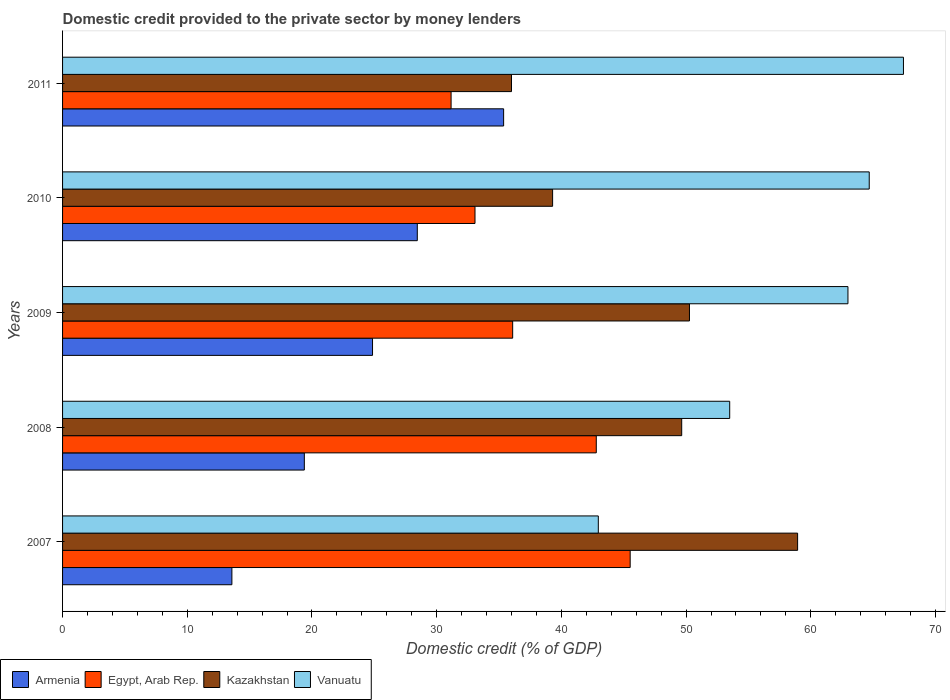How many different coloured bars are there?
Offer a very short reply. 4. How many groups of bars are there?
Offer a terse response. 5. How many bars are there on the 2nd tick from the bottom?
Ensure brevity in your answer.  4. What is the label of the 5th group of bars from the top?
Provide a succinct answer. 2007. In how many cases, is the number of bars for a given year not equal to the number of legend labels?
Provide a succinct answer. 0. What is the domestic credit provided to the private sector by money lenders in Kazakhstan in 2010?
Make the answer very short. 39.3. Across all years, what is the maximum domestic credit provided to the private sector by money lenders in Armenia?
Your answer should be compact. 35.37. Across all years, what is the minimum domestic credit provided to the private sector by money lenders in Vanuatu?
Provide a short and direct response. 42.96. In which year was the domestic credit provided to the private sector by money lenders in Egypt, Arab Rep. maximum?
Your response must be concise. 2007. In which year was the domestic credit provided to the private sector by money lenders in Egypt, Arab Rep. minimum?
Your answer should be compact. 2011. What is the total domestic credit provided to the private sector by money lenders in Egypt, Arab Rep. in the graph?
Keep it short and to the point. 188.63. What is the difference between the domestic credit provided to the private sector by money lenders in Kazakhstan in 2007 and that in 2008?
Your response must be concise. 9.29. What is the difference between the domestic credit provided to the private sector by money lenders in Vanuatu in 2010 and the domestic credit provided to the private sector by money lenders in Kazakhstan in 2008?
Keep it short and to the point. 15.04. What is the average domestic credit provided to the private sector by money lenders in Kazakhstan per year?
Keep it short and to the point. 46.83. In the year 2008, what is the difference between the domestic credit provided to the private sector by money lenders in Armenia and domestic credit provided to the private sector by money lenders in Vanuatu?
Ensure brevity in your answer.  -34.11. What is the ratio of the domestic credit provided to the private sector by money lenders in Kazakhstan in 2010 to that in 2011?
Your response must be concise. 1.09. Is the domestic credit provided to the private sector by money lenders in Kazakhstan in 2009 less than that in 2011?
Make the answer very short. No. Is the difference between the domestic credit provided to the private sector by money lenders in Armenia in 2007 and 2011 greater than the difference between the domestic credit provided to the private sector by money lenders in Vanuatu in 2007 and 2011?
Provide a short and direct response. Yes. What is the difference between the highest and the second highest domestic credit provided to the private sector by money lenders in Egypt, Arab Rep.?
Ensure brevity in your answer.  2.72. What is the difference between the highest and the lowest domestic credit provided to the private sector by money lenders in Kazakhstan?
Give a very brief answer. 22.94. In how many years, is the domestic credit provided to the private sector by money lenders in Kazakhstan greater than the average domestic credit provided to the private sector by money lenders in Kazakhstan taken over all years?
Keep it short and to the point. 3. What does the 1st bar from the top in 2007 represents?
Offer a terse response. Vanuatu. What does the 4th bar from the bottom in 2010 represents?
Provide a short and direct response. Vanuatu. How many years are there in the graph?
Your response must be concise. 5. What is the difference between two consecutive major ticks on the X-axis?
Provide a succinct answer. 10. Does the graph contain any zero values?
Keep it short and to the point. No. Does the graph contain grids?
Keep it short and to the point. No. How many legend labels are there?
Ensure brevity in your answer.  4. What is the title of the graph?
Provide a succinct answer. Domestic credit provided to the private sector by money lenders. Does "Iraq" appear as one of the legend labels in the graph?
Offer a terse response. No. What is the label or title of the X-axis?
Your response must be concise. Domestic credit (% of GDP). What is the Domestic credit (% of GDP) of Armenia in 2007?
Keep it short and to the point. 13.58. What is the Domestic credit (% of GDP) in Egypt, Arab Rep. in 2007?
Give a very brief answer. 45.52. What is the Domestic credit (% of GDP) in Kazakhstan in 2007?
Offer a very short reply. 58.94. What is the Domestic credit (% of GDP) of Vanuatu in 2007?
Your response must be concise. 42.96. What is the Domestic credit (% of GDP) in Armenia in 2008?
Offer a very short reply. 19.39. What is the Domestic credit (% of GDP) in Egypt, Arab Rep. in 2008?
Make the answer very short. 42.8. What is the Domestic credit (% of GDP) in Kazakhstan in 2008?
Give a very brief answer. 49.65. What is the Domestic credit (% of GDP) in Vanuatu in 2008?
Ensure brevity in your answer.  53.5. What is the Domestic credit (% of GDP) of Armenia in 2009?
Make the answer very short. 24.85. What is the Domestic credit (% of GDP) in Egypt, Arab Rep. in 2009?
Ensure brevity in your answer.  36.09. What is the Domestic credit (% of GDP) in Kazakhstan in 2009?
Your answer should be very brief. 50.27. What is the Domestic credit (% of GDP) in Vanuatu in 2009?
Offer a terse response. 62.98. What is the Domestic credit (% of GDP) in Armenia in 2010?
Your response must be concise. 28.45. What is the Domestic credit (% of GDP) of Egypt, Arab Rep. in 2010?
Keep it short and to the point. 33.07. What is the Domestic credit (% of GDP) in Kazakhstan in 2010?
Your answer should be compact. 39.3. What is the Domestic credit (% of GDP) in Vanuatu in 2010?
Provide a succinct answer. 64.69. What is the Domestic credit (% of GDP) of Armenia in 2011?
Provide a succinct answer. 35.37. What is the Domestic credit (% of GDP) of Egypt, Arab Rep. in 2011?
Your response must be concise. 31.15. What is the Domestic credit (% of GDP) of Kazakhstan in 2011?
Provide a succinct answer. 36. What is the Domestic credit (% of GDP) of Vanuatu in 2011?
Your answer should be compact. 67.43. Across all years, what is the maximum Domestic credit (% of GDP) of Armenia?
Offer a terse response. 35.37. Across all years, what is the maximum Domestic credit (% of GDP) of Egypt, Arab Rep.?
Provide a short and direct response. 45.52. Across all years, what is the maximum Domestic credit (% of GDP) in Kazakhstan?
Your answer should be compact. 58.94. Across all years, what is the maximum Domestic credit (% of GDP) in Vanuatu?
Offer a very short reply. 67.43. Across all years, what is the minimum Domestic credit (% of GDP) in Armenia?
Provide a succinct answer. 13.58. Across all years, what is the minimum Domestic credit (% of GDP) of Egypt, Arab Rep.?
Provide a succinct answer. 31.15. Across all years, what is the minimum Domestic credit (% of GDP) of Kazakhstan?
Offer a very short reply. 36. Across all years, what is the minimum Domestic credit (% of GDP) in Vanuatu?
Your answer should be very brief. 42.96. What is the total Domestic credit (% of GDP) in Armenia in the graph?
Your answer should be compact. 121.63. What is the total Domestic credit (% of GDP) in Egypt, Arab Rep. in the graph?
Your response must be concise. 188.63. What is the total Domestic credit (% of GDP) in Kazakhstan in the graph?
Give a very brief answer. 234.15. What is the total Domestic credit (% of GDP) in Vanuatu in the graph?
Ensure brevity in your answer.  291.55. What is the difference between the Domestic credit (% of GDP) in Armenia in 2007 and that in 2008?
Offer a terse response. -5.81. What is the difference between the Domestic credit (% of GDP) in Egypt, Arab Rep. in 2007 and that in 2008?
Keep it short and to the point. 2.72. What is the difference between the Domestic credit (% of GDP) of Kazakhstan in 2007 and that in 2008?
Make the answer very short. 9.29. What is the difference between the Domestic credit (% of GDP) in Vanuatu in 2007 and that in 2008?
Your answer should be very brief. -10.54. What is the difference between the Domestic credit (% of GDP) in Armenia in 2007 and that in 2009?
Your answer should be compact. -11.28. What is the difference between the Domestic credit (% of GDP) in Egypt, Arab Rep. in 2007 and that in 2009?
Make the answer very short. 9.42. What is the difference between the Domestic credit (% of GDP) of Kazakhstan in 2007 and that in 2009?
Provide a succinct answer. 8.67. What is the difference between the Domestic credit (% of GDP) in Vanuatu in 2007 and that in 2009?
Your answer should be compact. -20.02. What is the difference between the Domestic credit (% of GDP) of Armenia in 2007 and that in 2010?
Make the answer very short. -14.87. What is the difference between the Domestic credit (% of GDP) of Egypt, Arab Rep. in 2007 and that in 2010?
Keep it short and to the point. 12.44. What is the difference between the Domestic credit (% of GDP) in Kazakhstan in 2007 and that in 2010?
Your answer should be very brief. 19.65. What is the difference between the Domestic credit (% of GDP) of Vanuatu in 2007 and that in 2010?
Provide a succinct answer. -21.73. What is the difference between the Domestic credit (% of GDP) of Armenia in 2007 and that in 2011?
Your answer should be compact. -21.79. What is the difference between the Domestic credit (% of GDP) in Egypt, Arab Rep. in 2007 and that in 2011?
Keep it short and to the point. 14.36. What is the difference between the Domestic credit (% of GDP) in Kazakhstan in 2007 and that in 2011?
Keep it short and to the point. 22.94. What is the difference between the Domestic credit (% of GDP) in Vanuatu in 2007 and that in 2011?
Make the answer very short. -24.47. What is the difference between the Domestic credit (% of GDP) in Armenia in 2008 and that in 2009?
Offer a very short reply. -5.47. What is the difference between the Domestic credit (% of GDP) in Egypt, Arab Rep. in 2008 and that in 2009?
Give a very brief answer. 6.7. What is the difference between the Domestic credit (% of GDP) in Kazakhstan in 2008 and that in 2009?
Offer a terse response. -0.62. What is the difference between the Domestic credit (% of GDP) of Vanuatu in 2008 and that in 2009?
Your answer should be compact. -9.48. What is the difference between the Domestic credit (% of GDP) of Armenia in 2008 and that in 2010?
Keep it short and to the point. -9.06. What is the difference between the Domestic credit (% of GDP) in Egypt, Arab Rep. in 2008 and that in 2010?
Provide a short and direct response. 9.73. What is the difference between the Domestic credit (% of GDP) in Kazakhstan in 2008 and that in 2010?
Your answer should be compact. 10.35. What is the difference between the Domestic credit (% of GDP) in Vanuatu in 2008 and that in 2010?
Offer a terse response. -11.19. What is the difference between the Domestic credit (% of GDP) of Armenia in 2008 and that in 2011?
Offer a very short reply. -15.98. What is the difference between the Domestic credit (% of GDP) in Egypt, Arab Rep. in 2008 and that in 2011?
Keep it short and to the point. 11.64. What is the difference between the Domestic credit (% of GDP) in Kazakhstan in 2008 and that in 2011?
Ensure brevity in your answer.  13.65. What is the difference between the Domestic credit (% of GDP) in Vanuatu in 2008 and that in 2011?
Provide a succinct answer. -13.93. What is the difference between the Domestic credit (% of GDP) in Armenia in 2009 and that in 2010?
Give a very brief answer. -3.59. What is the difference between the Domestic credit (% of GDP) in Egypt, Arab Rep. in 2009 and that in 2010?
Provide a succinct answer. 3.02. What is the difference between the Domestic credit (% of GDP) of Kazakhstan in 2009 and that in 2010?
Give a very brief answer. 10.97. What is the difference between the Domestic credit (% of GDP) in Vanuatu in 2009 and that in 2010?
Offer a terse response. -1.71. What is the difference between the Domestic credit (% of GDP) of Armenia in 2009 and that in 2011?
Ensure brevity in your answer.  -10.51. What is the difference between the Domestic credit (% of GDP) in Egypt, Arab Rep. in 2009 and that in 2011?
Offer a very short reply. 4.94. What is the difference between the Domestic credit (% of GDP) in Kazakhstan in 2009 and that in 2011?
Offer a very short reply. 14.27. What is the difference between the Domestic credit (% of GDP) in Vanuatu in 2009 and that in 2011?
Ensure brevity in your answer.  -4.45. What is the difference between the Domestic credit (% of GDP) in Armenia in 2010 and that in 2011?
Offer a very short reply. -6.92. What is the difference between the Domestic credit (% of GDP) of Egypt, Arab Rep. in 2010 and that in 2011?
Your answer should be very brief. 1.92. What is the difference between the Domestic credit (% of GDP) in Kazakhstan in 2010 and that in 2011?
Give a very brief answer. 3.3. What is the difference between the Domestic credit (% of GDP) of Vanuatu in 2010 and that in 2011?
Provide a succinct answer. -2.74. What is the difference between the Domestic credit (% of GDP) in Armenia in 2007 and the Domestic credit (% of GDP) in Egypt, Arab Rep. in 2008?
Keep it short and to the point. -29.22. What is the difference between the Domestic credit (% of GDP) in Armenia in 2007 and the Domestic credit (% of GDP) in Kazakhstan in 2008?
Offer a very short reply. -36.07. What is the difference between the Domestic credit (% of GDP) of Armenia in 2007 and the Domestic credit (% of GDP) of Vanuatu in 2008?
Offer a terse response. -39.92. What is the difference between the Domestic credit (% of GDP) of Egypt, Arab Rep. in 2007 and the Domestic credit (% of GDP) of Kazakhstan in 2008?
Provide a short and direct response. -4.13. What is the difference between the Domestic credit (% of GDP) of Egypt, Arab Rep. in 2007 and the Domestic credit (% of GDP) of Vanuatu in 2008?
Offer a terse response. -7.98. What is the difference between the Domestic credit (% of GDP) in Kazakhstan in 2007 and the Domestic credit (% of GDP) in Vanuatu in 2008?
Your response must be concise. 5.44. What is the difference between the Domestic credit (% of GDP) in Armenia in 2007 and the Domestic credit (% of GDP) in Egypt, Arab Rep. in 2009?
Offer a very short reply. -22.51. What is the difference between the Domestic credit (% of GDP) in Armenia in 2007 and the Domestic credit (% of GDP) in Kazakhstan in 2009?
Offer a terse response. -36.69. What is the difference between the Domestic credit (% of GDP) in Armenia in 2007 and the Domestic credit (% of GDP) in Vanuatu in 2009?
Make the answer very short. -49.4. What is the difference between the Domestic credit (% of GDP) in Egypt, Arab Rep. in 2007 and the Domestic credit (% of GDP) in Kazakhstan in 2009?
Offer a terse response. -4.75. What is the difference between the Domestic credit (% of GDP) in Egypt, Arab Rep. in 2007 and the Domestic credit (% of GDP) in Vanuatu in 2009?
Give a very brief answer. -17.46. What is the difference between the Domestic credit (% of GDP) in Kazakhstan in 2007 and the Domestic credit (% of GDP) in Vanuatu in 2009?
Offer a terse response. -4.04. What is the difference between the Domestic credit (% of GDP) of Armenia in 2007 and the Domestic credit (% of GDP) of Egypt, Arab Rep. in 2010?
Offer a terse response. -19.49. What is the difference between the Domestic credit (% of GDP) of Armenia in 2007 and the Domestic credit (% of GDP) of Kazakhstan in 2010?
Your answer should be compact. -25.72. What is the difference between the Domestic credit (% of GDP) of Armenia in 2007 and the Domestic credit (% of GDP) of Vanuatu in 2010?
Provide a succinct answer. -51.11. What is the difference between the Domestic credit (% of GDP) in Egypt, Arab Rep. in 2007 and the Domestic credit (% of GDP) in Kazakhstan in 2010?
Give a very brief answer. 6.22. What is the difference between the Domestic credit (% of GDP) in Egypt, Arab Rep. in 2007 and the Domestic credit (% of GDP) in Vanuatu in 2010?
Make the answer very short. -19.17. What is the difference between the Domestic credit (% of GDP) of Kazakhstan in 2007 and the Domestic credit (% of GDP) of Vanuatu in 2010?
Give a very brief answer. -5.74. What is the difference between the Domestic credit (% of GDP) of Armenia in 2007 and the Domestic credit (% of GDP) of Egypt, Arab Rep. in 2011?
Your response must be concise. -17.58. What is the difference between the Domestic credit (% of GDP) of Armenia in 2007 and the Domestic credit (% of GDP) of Kazakhstan in 2011?
Your response must be concise. -22.42. What is the difference between the Domestic credit (% of GDP) in Armenia in 2007 and the Domestic credit (% of GDP) in Vanuatu in 2011?
Provide a short and direct response. -53.85. What is the difference between the Domestic credit (% of GDP) in Egypt, Arab Rep. in 2007 and the Domestic credit (% of GDP) in Kazakhstan in 2011?
Provide a succinct answer. 9.52. What is the difference between the Domestic credit (% of GDP) in Egypt, Arab Rep. in 2007 and the Domestic credit (% of GDP) in Vanuatu in 2011?
Keep it short and to the point. -21.91. What is the difference between the Domestic credit (% of GDP) in Kazakhstan in 2007 and the Domestic credit (% of GDP) in Vanuatu in 2011?
Keep it short and to the point. -8.49. What is the difference between the Domestic credit (% of GDP) in Armenia in 2008 and the Domestic credit (% of GDP) in Egypt, Arab Rep. in 2009?
Your response must be concise. -16.71. What is the difference between the Domestic credit (% of GDP) of Armenia in 2008 and the Domestic credit (% of GDP) of Kazakhstan in 2009?
Offer a terse response. -30.88. What is the difference between the Domestic credit (% of GDP) of Armenia in 2008 and the Domestic credit (% of GDP) of Vanuatu in 2009?
Offer a very short reply. -43.59. What is the difference between the Domestic credit (% of GDP) of Egypt, Arab Rep. in 2008 and the Domestic credit (% of GDP) of Kazakhstan in 2009?
Your answer should be compact. -7.47. What is the difference between the Domestic credit (% of GDP) of Egypt, Arab Rep. in 2008 and the Domestic credit (% of GDP) of Vanuatu in 2009?
Your answer should be compact. -20.18. What is the difference between the Domestic credit (% of GDP) of Kazakhstan in 2008 and the Domestic credit (% of GDP) of Vanuatu in 2009?
Give a very brief answer. -13.33. What is the difference between the Domestic credit (% of GDP) of Armenia in 2008 and the Domestic credit (% of GDP) of Egypt, Arab Rep. in 2010?
Offer a very short reply. -13.69. What is the difference between the Domestic credit (% of GDP) of Armenia in 2008 and the Domestic credit (% of GDP) of Kazakhstan in 2010?
Your response must be concise. -19.91. What is the difference between the Domestic credit (% of GDP) of Armenia in 2008 and the Domestic credit (% of GDP) of Vanuatu in 2010?
Your response must be concise. -45.3. What is the difference between the Domestic credit (% of GDP) in Egypt, Arab Rep. in 2008 and the Domestic credit (% of GDP) in Kazakhstan in 2010?
Give a very brief answer. 3.5. What is the difference between the Domestic credit (% of GDP) in Egypt, Arab Rep. in 2008 and the Domestic credit (% of GDP) in Vanuatu in 2010?
Keep it short and to the point. -21.89. What is the difference between the Domestic credit (% of GDP) in Kazakhstan in 2008 and the Domestic credit (% of GDP) in Vanuatu in 2010?
Offer a terse response. -15.04. What is the difference between the Domestic credit (% of GDP) in Armenia in 2008 and the Domestic credit (% of GDP) in Egypt, Arab Rep. in 2011?
Your answer should be compact. -11.77. What is the difference between the Domestic credit (% of GDP) in Armenia in 2008 and the Domestic credit (% of GDP) in Kazakhstan in 2011?
Your answer should be compact. -16.61. What is the difference between the Domestic credit (% of GDP) in Armenia in 2008 and the Domestic credit (% of GDP) in Vanuatu in 2011?
Your response must be concise. -48.04. What is the difference between the Domestic credit (% of GDP) of Egypt, Arab Rep. in 2008 and the Domestic credit (% of GDP) of Kazakhstan in 2011?
Keep it short and to the point. 6.8. What is the difference between the Domestic credit (% of GDP) of Egypt, Arab Rep. in 2008 and the Domestic credit (% of GDP) of Vanuatu in 2011?
Give a very brief answer. -24.63. What is the difference between the Domestic credit (% of GDP) of Kazakhstan in 2008 and the Domestic credit (% of GDP) of Vanuatu in 2011?
Make the answer very short. -17.78. What is the difference between the Domestic credit (% of GDP) in Armenia in 2009 and the Domestic credit (% of GDP) in Egypt, Arab Rep. in 2010?
Provide a succinct answer. -8.22. What is the difference between the Domestic credit (% of GDP) of Armenia in 2009 and the Domestic credit (% of GDP) of Kazakhstan in 2010?
Your answer should be compact. -14.44. What is the difference between the Domestic credit (% of GDP) of Armenia in 2009 and the Domestic credit (% of GDP) of Vanuatu in 2010?
Make the answer very short. -39.83. What is the difference between the Domestic credit (% of GDP) in Egypt, Arab Rep. in 2009 and the Domestic credit (% of GDP) in Kazakhstan in 2010?
Your answer should be compact. -3.2. What is the difference between the Domestic credit (% of GDP) of Egypt, Arab Rep. in 2009 and the Domestic credit (% of GDP) of Vanuatu in 2010?
Provide a short and direct response. -28.59. What is the difference between the Domestic credit (% of GDP) of Kazakhstan in 2009 and the Domestic credit (% of GDP) of Vanuatu in 2010?
Make the answer very short. -14.42. What is the difference between the Domestic credit (% of GDP) of Armenia in 2009 and the Domestic credit (% of GDP) of Kazakhstan in 2011?
Your answer should be very brief. -11.14. What is the difference between the Domestic credit (% of GDP) of Armenia in 2009 and the Domestic credit (% of GDP) of Vanuatu in 2011?
Provide a succinct answer. -42.57. What is the difference between the Domestic credit (% of GDP) in Egypt, Arab Rep. in 2009 and the Domestic credit (% of GDP) in Kazakhstan in 2011?
Your answer should be compact. 0.09. What is the difference between the Domestic credit (% of GDP) of Egypt, Arab Rep. in 2009 and the Domestic credit (% of GDP) of Vanuatu in 2011?
Your response must be concise. -31.34. What is the difference between the Domestic credit (% of GDP) in Kazakhstan in 2009 and the Domestic credit (% of GDP) in Vanuatu in 2011?
Make the answer very short. -17.16. What is the difference between the Domestic credit (% of GDP) of Armenia in 2010 and the Domestic credit (% of GDP) of Egypt, Arab Rep. in 2011?
Your answer should be very brief. -2.71. What is the difference between the Domestic credit (% of GDP) of Armenia in 2010 and the Domestic credit (% of GDP) of Kazakhstan in 2011?
Give a very brief answer. -7.55. What is the difference between the Domestic credit (% of GDP) in Armenia in 2010 and the Domestic credit (% of GDP) in Vanuatu in 2011?
Provide a short and direct response. -38.98. What is the difference between the Domestic credit (% of GDP) in Egypt, Arab Rep. in 2010 and the Domestic credit (% of GDP) in Kazakhstan in 2011?
Give a very brief answer. -2.93. What is the difference between the Domestic credit (% of GDP) in Egypt, Arab Rep. in 2010 and the Domestic credit (% of GDP) in Vanuatu in 2011?
Provide a succinct answer. -34.36. What is the difference between the Domestic credit (% of GDP) in Kazakhstan in 2010 and the Domestic credit (% of GDP) in Vanuatu in 2011?
Your response must be concise. -28.13. What is the average Domestic credit (% of GDP) in Armenia per year?
Ensure brevity in your answer.  24.33. What is the average Domestic credit (% of GDP) in Egypt, Arab Rep. per year?
Provide a short and direct response. 37.73. What is the average Domestic credit (% of GDP) in Kazakhstan per year?
Your answer should be very brief. 46.83. What is the average Domestic credit (% of GDP) in Vanuatu per year?
Provide a succinct answer. 58.31. In the year 2007, what is the difference between the Domestic credit (% of GDP) of Armenia and Domestic credit (% of GDP) of Egypt, Arab Rep.?
Provide a succinct answer. -31.94. In the year 2007, what is the difference between the Domestic credit (% of GDP) in Armenia and Domestic credit (% of GDP) in Kazakhstan?
Provide a succinct answer. -45.36. In the year 2007, what is the difference between the Domestic credit (% of GDP) of Armenia and Domestic credit (% of GDP) of Vanuatu?
Your answer should be very brief. -29.38. In the year 2007, what is the difference between the Domestic credit (% of GDP) in Egypt, Arab Rep. and Domestic credit (% of GDP) in Kazakhstan?
Ensure brevity in your answer.  -13.43. In the year 2007, what is the difference between the Domestic credit (% of GDP) in Egypt, Arab Rep. and Domestic credit (% of GDP) in Vanuatu?
Ensure brevity in your answer.  2.56. In the year 2007, what is the difference between the Domestic credit (% of GDP) in Kazakhstan and Domestic credit (% of GDP) in Vanuatu?
Make the answer very short. 15.98. In the year 2008, what is the difference between the Domestic credit (% of GDP) of Armenia and Domestic credit (% of GDP) of Egypt, Arab Rep.?
Offer a terse response. -23.41. In the year 2008, what is the difference between the Domestic credit (% of GDP) of Armenia and Domestic credit (% of GDP) of Kazakhstan?
Provide a short and direct response. -30.26. In the year 2008, what is the difference between the Domestic credit (% of GDP) of Armenia and Domestic credit (% of GDP) of Vanuatu?
Provide a succinct answer. -34.11. In the year 2008, what is the difference between the Domestic credit (% of GDP) of Egypt, Arab Rep. and Domestic credit (% of GDP) of Kazakhstan?
Give a very brief answer. -6.85. In the year 2008, what is the difference between the Domestic credit (% of GDP) in Egypt, Arab Rep. and Domestic credit (% of GDP) in Vanuatu?
Provide a succinct answer. -10.7. In the year 2008, what is the difference between the Domestic credit (% of GDP) of Kazakhstan and Domestic credit (% of GDP) of Vanuatu?
Offer a very short reply. -3.85. In the year 2009, what is the difference between the Domestic credit (% of GDP) in Armenia and Domestic credit (% of GDP) in Egypt, Arab Rep.?
Provide a short and direct response. -11.24. In the year 2009, what is the difference between the Domestic credit (% of GDP) in Armenia and Domestic credit (% of GDP) in Kazakhstan?
Offer a very short reply. -25.41. In the year 2009, what is the difference between the Domestic credit (% of GDP) in Armenia and Domestic credit (% of GDP) in Vanuatu?
Offer a very short reply. -38.12. In the year 2009, what is the difference between the Domestic credit (% of GDP) of Egypt, Arab Rep. and Domestic credit (% of GDP) of Kazakhstan?
Ensure brevity in your answer.  -14.18. In the year 2009, what is the difference between the Domestic credit (% of GDP) of Egypt, Arab Rep. and Domestic credit (% of GDP) of Vanuatu?
Ensure brevity in your answer.  -26.89. In the year 2009, what is the difference between the Domestic credit (% of GDP) in Kazakhstan and Domestic credit (% of GDP) in Vanuatu?
Offer a terse response. -12.71. In the year 2010, what is the difference between the Domestic credit (% of GDP) of Armenia and Domestic credit (% of GDP) of Egypt, Arab Rep.?
Offer a very short reply. -4.63. In the year 2010, what is the difference between the Domestic credit (% of GDP) of Armenia and Domestic credit (% of GDP) of Kazakhstan?
Ensure brevity in your answer.  -10.85. In the year 2010, what is the difference between the Domestic credit (% of GDP) in Armenia and Domestic credit (% of GDP) in Vanuatu?
Your answer should be compact. -36.24. In the year 2010, what is the difference between the Domestic credit (% of GDP) in Egypt, Arab Rep. and Domestic credit (% of GDP) in Kazakhstan?
Provide a succinct answer. -6.22. In the year 2010, what is the difference between the Domestic credit (% of GDP) of Egypt, Arab Rep. and Domestic credit (% of GDP) of Vanuatu?
Make the answer very short. -31.61. In the year 2010, what is the difference between the Domestic credit (% of GDP) in Kazakhstan and Domestic credit (% of GDP) in Vanuatu?
Keep it short and to the point. -25.39. In the year 2011, what is the difference between the Domestic credit (% of GDP) in Armenia and Domestic credit (% of GDP) in Egypt, Arab Rep.?
Your answer should be compact. 4.21. In the year 2011, what is the difference between the Domestic credit (% of GDP) in Armenia and Domestic credit (% of GDP) in Kazakhstan?
Make the answer very short. -0.63. In the year 2011, what is the difference between the Domestic credit (% of GDP) of Armenia and Domestic credit (% of GDP) of Vanuatu?
Provide a short and direct response. -32.06. In the year 2011, what is the difference between the Domestic credit (% of GDP) in Egypt, Arab Rep. and Domestic credit (% of GDP) in Kazakhstan?
Offer a very short reply. -4.84. In the year 2011, what is the difference between the Domestic credit (% of GDP) in Egypt, Arab Rep. and Domestic credit (% of GDP) in Vanuatu?
Offer a very short reply. -36.27. In the year 2011, what is the difference between the Domestic credit (% of GDP) of Kazakhstan and Domestic credit (% of GDP) of Vanuatu?
Provide a succinct answer. -31.43. What is the ratio of the Domestic credit (% of GDP) in Armenia in 2007 to that in 2008?
Ensure brevity in your answer.  0.7. What is the ratio of the Domestic credit (% of GDP) of Egypt, Arab Rep. in 2007 to that in 2008?
Provide a succinct answer. 1.06. What is the ratio of the Domestic credit (% of GDP) in Kazakhstan in 2007 to that in 2008?
Your response must be concise. 1.19. What is the ratio of the Domestic credit (% of GDP) of Vanuatu in 2007 to that in 2008?
Give a very brief answer. 0.8. What is the ratio of the Domestic credit (% of GDP) in Armenia in 2007 to that in 2009?
Keep it short and to the point. 0.55. What is the ratio of the Domestic credit (% of GDP) of Egypt, Arab Rep. in 2007 to that in 2009?
Keep it short and to the point. 1.26. What is the ratio of the Domestic credit (% of GDP) of Kazakhstan in 2007 to that in 2009?
Give a very brief answer. 1.17. What is the ratio of the Domestic credit (% of GDP) of Vanuatu in 2007 to that in 2009?
Give a very brief answer. 0.68. What is the ratio of the Domestic credit (% of GDP) in Armenia in 2007 to that in 2010?
Make the answer very short. 0.48. What is the ratio of the Domestic credit (% of GDP) in Egypt, Arab Rep. in 2007 to that in 2010?
Keep it short and to the point. 1.38. What is the ratio of the Domestic credit (% of GDP) of Kazakhstan in 2007 to that in 2010?
Make the answer very short. 1.5. What is the ratio of the Domestic credit (% of GDP) in Vanuatu in 2007 to that in 2010?
Make the answer very short. 0.66. What is the ratio of the Domestic credit (% of GDP) in Armenia in 2007 to that in 2011?
Make the answer very short. 0.38. What is the ratio of the Domestic credit (% of GDP) of Egypt, Arab Rep. in 2007 to that in 2011?
Offer a very short reply. 1.46. What is the ratio of the Domestic credit (% of GDP) in Kazakhstan in 2007 to that in 2011?
Offer a very short reply. 1.64. What is the ratio of the Domestic credit (% of GDP) in Vanuatu in 2007 to that in 2011?
Provide a short and direct response. 0.64. What is the ratio of the Domestic credit (% of GDP) of Armenia in 2008 to that in 2009?
Make the answer very short. 0.78. What is the ratio of the Domestic credit (% of GDP) of Egypt, Arab Rep. in 2008 to that in 2009?
Your answer should be very brief. 1.19. What is the ratio of the Domestic credit (% of GDP) in Kazakhstan in 2008 to that in 2009?
Offer a very short reply. 0.99. What is the ratio of the Domestic credit (% of GDP) in Vanuatu in 2008 to that in 2009?
Your answer should be very brief. 0.85. What is the ratio of the Domestic credit (% of GDP) of Armenia in 2008 to that in 2010?
Ensure brevity in your answer.  0.68. What is the ratio of the Domestic credit (% of GDP) of Egypt, Arab Rep. in 2008 to that in 2010?
Your answer should be very brief. 1.29. What is the ratio of the Domestic credit (% of GDP) in Kazakhstan in 2008 to that in 2010?
Your response must be concise. 1.26. What is the ratio of the Domestic credit (% of GDP) of Vanuatu in 2008 to that in 2010?
Ensure brevity in your answer.  0.83. What is the ratio of the Domestic credit (% of GDP) of Armenia in 2008 to that in 2011?
Offer a very short reply. 0.55. What is the ratio of the Domestic credit (% of GDP) of Egypt, Arab Rep. in 2008 to that in 2011?
Your response must be concise. 1.37. What is the ratio of the Domestic credit (% of GDP) of Kazakhstan in 2008 to that in 2011?
Offer a very short reply. 1.38. What is the ratio of the Domestic credit (% of GDP) of Vanuatu in 2008 to that in 2011?
Provide a succinct answer. 0.79. What is the ratio of the Domestic credit (% of GDP) in Armenia in 2009 to that in 2010?
Give a very brief answer. 0.87. What is the ratio of the Domestic credit (% of GDP) in Egypt, Arab Rep. in 2009 to that in 2010?
Ensure brevity in your answer.  1.09. What is the ratio of the Domestic credit (% of GDP) in Kazakhstan in 2009 to that in 2010?
Provide a short and direct response. 1.28. What is the ratio of the Domestic credit (% of GDP) of Vanuatu in 2009 to that in 2010?
Provide a short and direct response. 0.97. What is the ratio of the Domestic credit (% of GDP) in Armenia in 2009 to that in 2011?
Your answer should be compact. 0.7. What is the ratio of the Domestic credit (% of GDP) of Egypt, Arab Rep. in 2009 to that in 2011?
Ensure brevity in your answer.  1.16. What is the ratio of the Domestic credit (% of GDP) of Kazakhstan in 2009 to that in 2011?
Keep it short and to the point. 1.4. What is the ratio of the Domestic credit (% of GDP) of Vanuatu in 2009 to that in 2011?
Make the answer very short. 0.93. What is the ratio of the Domestic credit (% of GDP) in Armenia in 2010 to that in 2011?
Your response must be concise. 0.8. What is the ratio of the Domestic credit (% of GDP) of Egypt, Arab Rep. in 2010 to that in 2011?
Provide a short and direct response. 1.06. What is the ratio of the Domestic credit (% of GDP) in Kazakhstan in 2010 to that in 2011?
Give a very brief answer. 1.09. What is the ratio of the Domestic credit (% of GDP) in Vanuatu in 2010 to that in 2011?
Give a very brief answer. 0.96. What is the difference between the highest and the second highest Domestic credit (% of GDP) of Armenia?
Your response must be concise. 6.92. What is the difference between the highest and the second highest Domestic credit (% of GDP) of Egypt, Arab Rep.?
Keep it short and to the point. 2.72. What is the difference between the highest and the second highest Domestic credit (% of GDP) of Kazakhstan?
Offer a very short reply. 8.67. What is the difference between the highest and the second highest Domestic credit (% of GDP) of Vanuatu?
Offer a very short reply. 2.74. What is the difference between the highest and the lowest Domestic credit (% of GDP) of Armenia?
Keep it short and to the point. 21.79. What is the difference between the highest and the lowest Domestic credit (% of GDP) of Egypt, Arab Rep.?
Ensure brevity in your answer.  14.36. What is the difference between the highest and the lowest Domestic credit (% of GDP) of Kazakhstan?
Your response must be concise. 22.94. What is the difference between the highest and the lowest Domestic credit (% of GDP) in Vanuatu?
Offer a terse response. 24.47. 